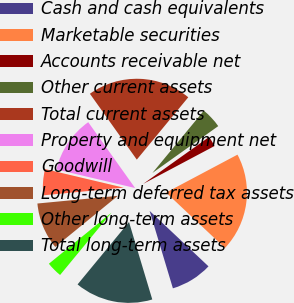Convert chart. <chart><loc_0><loc_0><loc_500><loc_500><pie_chart><fcel>Cash and cash equivalents<fcel>Marketable securities<fcel>Accounts receivable net<fcel>Other current assets<fcel>Total current assets<fcel>Property and equipment net<fcel>Goodwill<fcel>Long-term deferred tax assets<fcel>Other long-term assets<fcel>Total long-term assets<nl><fcel>8.33%<fcel>19.79%<fcel>2.08%<fcel>4.17%<fcel>20.83%<fcel>11.46%<fcel>5.21%<fcel>9.38%<fcel>3.13%<fcel>15.62%<nl></chart> 